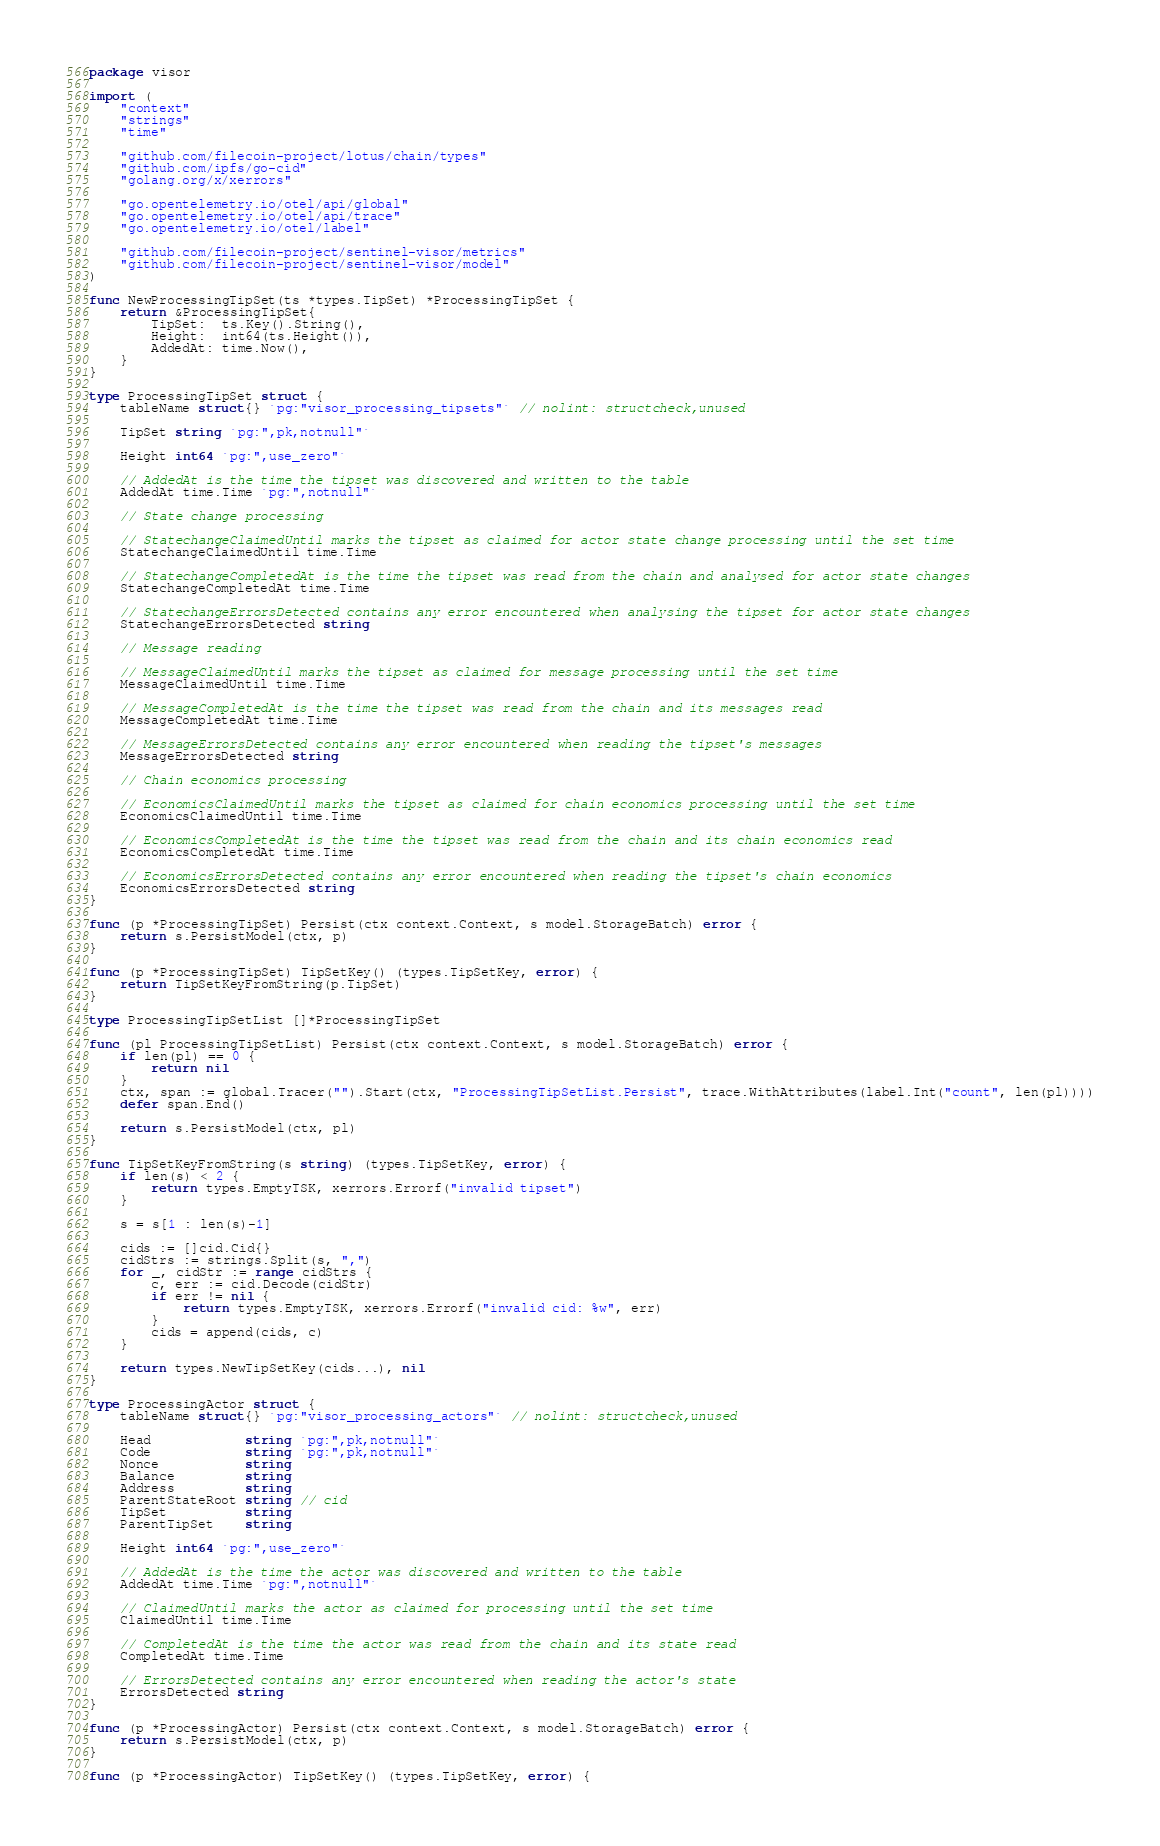Convert code to text. <code><loc_0><loc_0><loc_500><loc_500><_Go_>package visor

import (
	"context"
	"strings"
	"time"

	"github.com/filecoin-project/lotus/chain/types"
	"github.com/ipfs/go-cid"
	"golang.org/x/xerrors"

	"go.opentelemetry.io/otel/api/global"
	"go.opentelemetry.io/otel/api/trace"
	"go.opentelemetry.io/otel/label"

	"github.com/filecoin-project/sentinel-visor/metrics"
	"github.com/filecoin-project/sentinel-visor/model"
)

func NewProcessingTipSet(ts *types.TipSet) *ProcessingTipSet {
	return &ProcessingTipSet{
		TipSet:  ts.Key().String(),
		Height:  int64(ts.Height()),
		AddedAt: time.Now(),
	}
}

type ProcessingTipSet struct {
	tableName struct{} `pg:"visor_processing_tipsets"` // nolint: structcheck,unused

	TipSet string `pg:",pk,notnull"`

	Height int64 `pg:",use_zero"`

	// AddedAt is the time the tipset was discovered and written to the table
	AddedAt time.Time `pg:",notnull"`

	// State change processing

	// StatechangeClaimedUntil marks the tipset as claimed for actor state change processing until the set time
	StatechangeClaimedUntil time.Time

	// StatechangeCompletedAt is the time the tipset was read from the chain and analysed for actor state changes
	StatechangeCompletedAt time.Time

	// StatechangeErrorsDetected contains any error encountered when analysing the tipset for actor state changes
	StatechangeErrorsDetected string

	// Message reading

	// MessageClaimedUntil marks the tipset as claimed for message processing until the set time
	MessageClaimedUntil time.Time

	// MessageCompletedAt is the time the tipset was read from the chain and its messages read
	MessageCompletedAt time.Time

	// MessageErrorsDetected contains any error encountered when reading the tipset's messages
	MessageErrorsDetected string

	// Chain economics processing

	// EconomicsClaimedUntil marks the tipset as claimed for chain economics processing until the set time
	EconomicsClaimedUntil time.Time

	// EconomicsCompletedAt is the time the tipset was read from the chain and its chain economics read
	EconomicsCompletedAt time.Time

	// EconomicsErrorsDetected contains any error encountered when reading the tipset's chain economics
	EconomicsErrorsDetected string
}

func (p *ProcessingTipSet) Persist(ctx context.Context, s model.StorageBatch) error {
	return s.PersistModel(ctx, p)
}

func (p *ProcessingTipSet) TipSetKey() (types.TipSetKey, error) {
	return TipSetKeyFromString(p.TipSet)
}

type ProcessingTipSetList []*ProcessingTipSet

func (pl ProcessingTipSetList) Persist(ctx context.Context, s model.StorageBatch) error {
	if len(pl) == 0 {
		return nil
	}
	ctx, span := global.Tracer("").Start(ctx, "ProcessingTipSetList.Persist", trace.WithAttributes(label.Int("count", len(pl))))
	defer span.End()

	return s.PersistModel(ctx, pl)
}

func TipSetKeyFromString(s string) (types.TipSetKey, error) {
	if len(s) < 2 {
		return types.EmptyTSK, xerrors.Errorf("invalid tipset")
	}

	s = s[1 : len(s)-1]

	cids := []cid.Cid{}
	cidStrs := strings.Split(s, ",")
	for _, cidStr := range cidStrs {
		c, err := cid.Decode(cidStr)
		if err != nil {
			return types.EmptyTSK, xerrors.Errorf("invalid cid: %w", err)
		}
		cids = append(cids, c)
	}

	return types.NewTipSetKey(cids...), nil
}

type ProcessingActor struct {
	tableName struct{} `pg:"visor_processing_actors"` // nolint: structcheck,unused

	Head            string `pg:",pk,notnull"`
	Code            string `pg:",pk,notnull"`
	Nonce           string
	Balance         string
	Address         string
	ParentStateRoot string // cid
	TipSet          string
	ParentTipSet    string

	Height int64 `pg:",use_zero"`

	// AddedAt is the time the actor was discovered and written to the table
	AddedAt time.Time `pg:",notnull"`

	// ClaimedUntil marks the actor as claimed for processing until the set time
	ClaimedUntil time.Time

	// CompletedAt is the time the actor was read from the chain and its state read
	CompletedAt time.Time

	// ErrorsDetected contains any error encountered when reading the actor's state
	ErrorsDetected string
}

func (p *ProcessingActor) Persist(ctx context.Context, s model.StorageBatch) error {
	return s.PersistModel(ctx, p)
}

func (p *ProcessingActor) TipSetKey() (types.TipSetKey, error) {</code> 